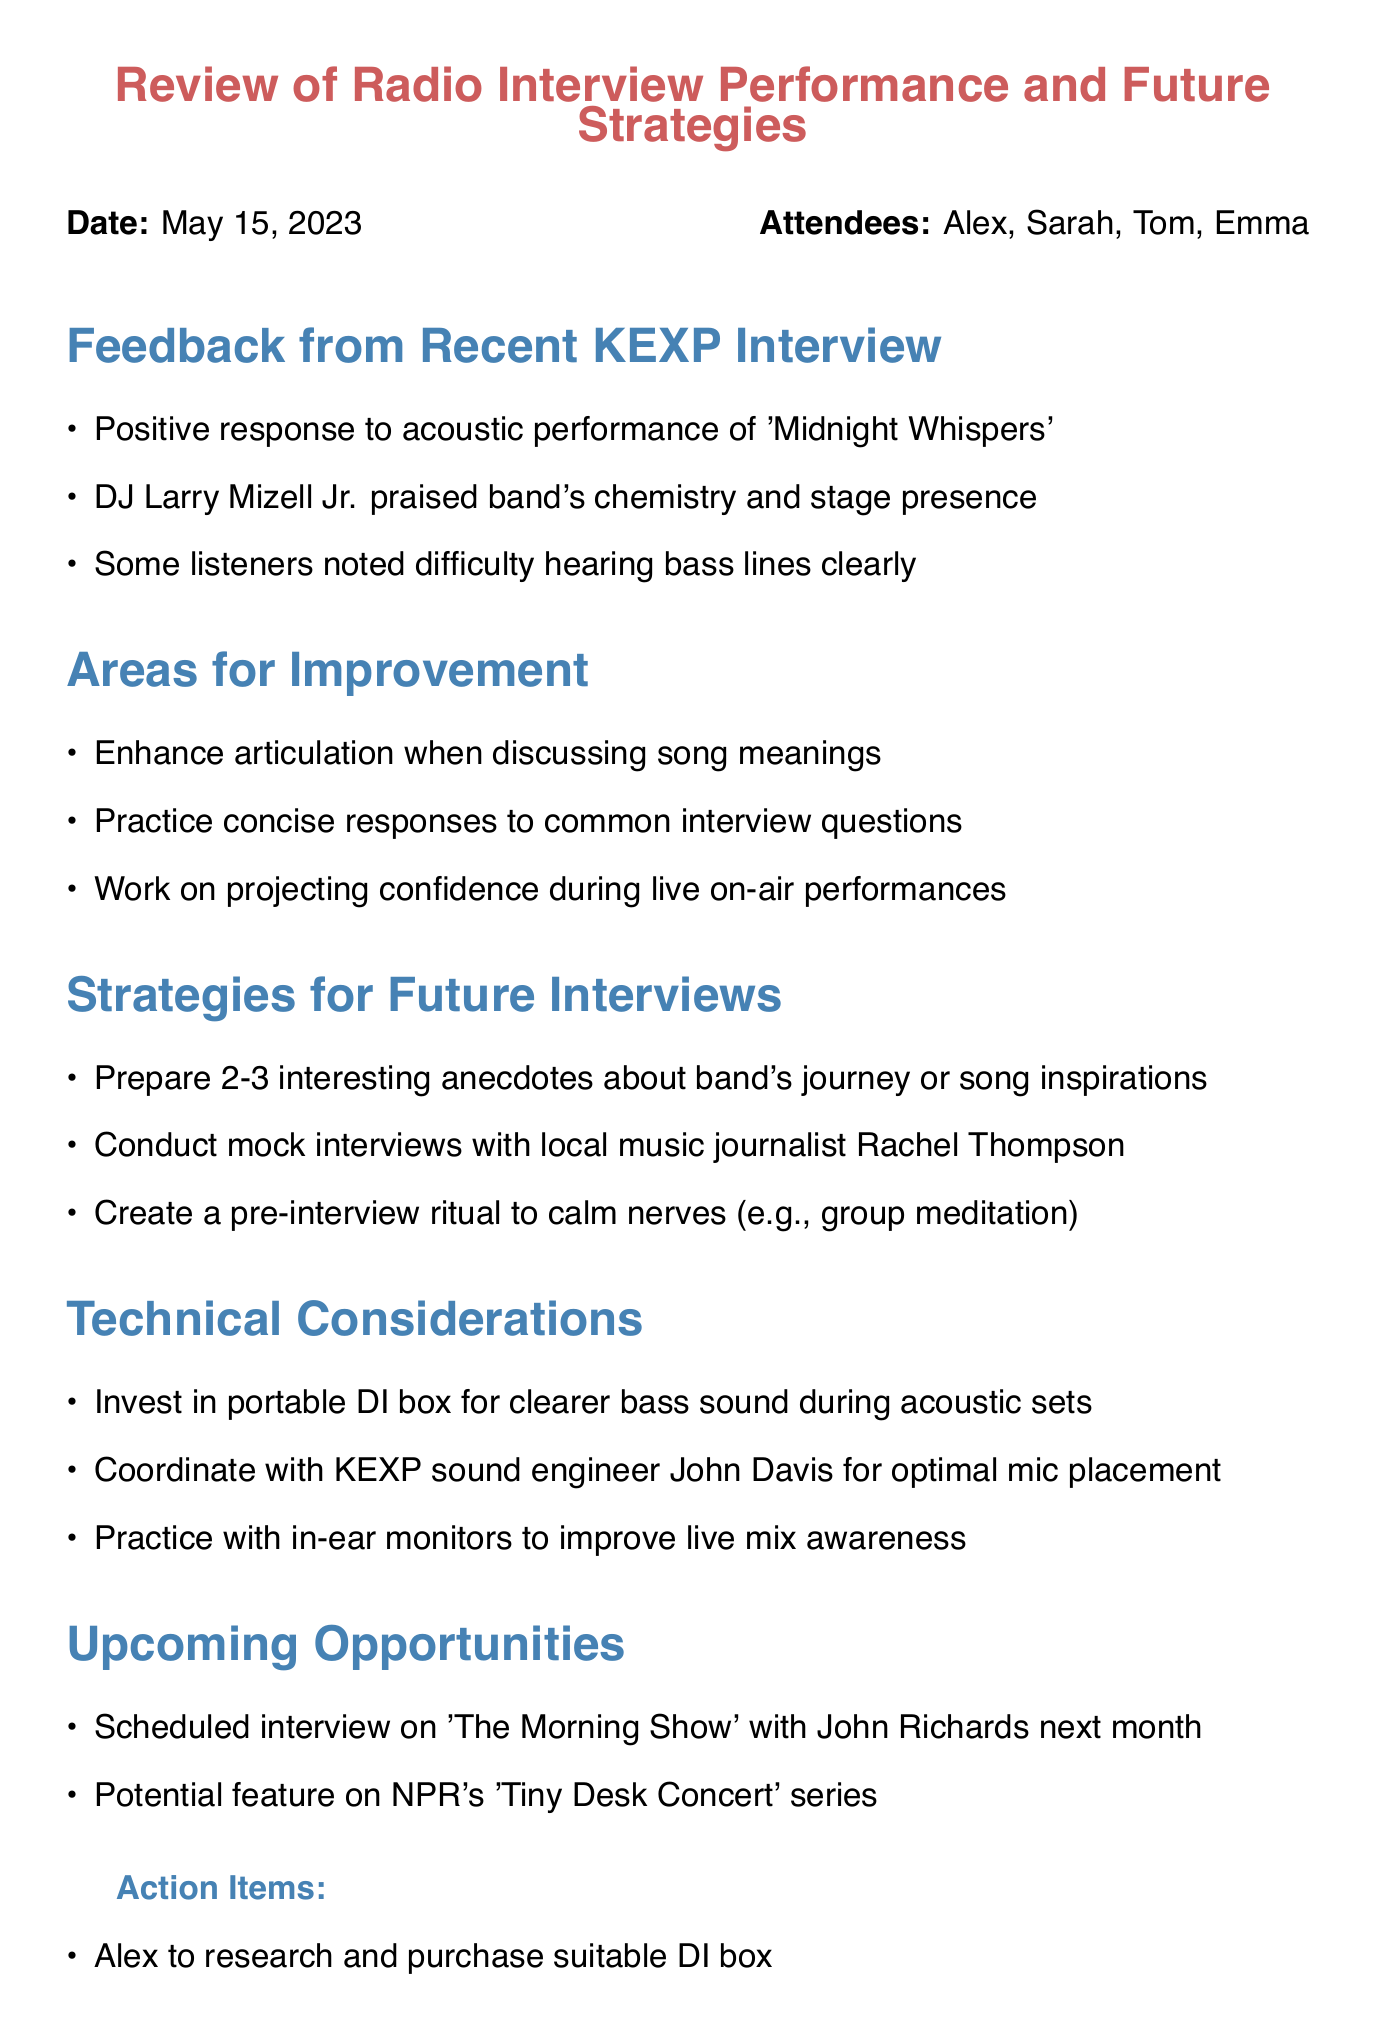What was the date of the meeting? The date of the meeting is mentioned in the document under the title section.
Answer: May 15, 2023 Who praised the band's chemistry during the interview? This information can be found in the feedback section, where a specific DJ is mentioned.
Answer: DJ Larry Mizell Jr What song received a positive response during the interview? The song is specifically stated in the feedback section of the document.
Answer: Midnight Whispers What is one area the band needs to improve according to the meeting? The areas for improvement are listed in a section of the document, which includes this point.
Answer: Enhance articulation when discussing song meanings What is one of the upcoming opportunities for the band mentioned in the document? The upcoming opportunities section lists potential interviews and features.
Answer: Scheduled interview on 'The Morning Show' What action item is assigned to Alex? The action items section specifies the tasks assigned to each band member.
Answer: Alex to research and purchase suitable DI box Why should the band invest in a portable DI box? The document explains the purpose of investing in this equipment under technical considerations.
Answer: For clearer bass sound during acoustic sets How many interesting anecdotes should the band prepare for interviews? The number is mentioned in the strategies section for future interviews.
Answer: 2-3 What is the purpose of conducting mock interviews? This reasoning can be derived from the strategies aimed at improving interview performance.
Answer: To practice responses and build confidence 